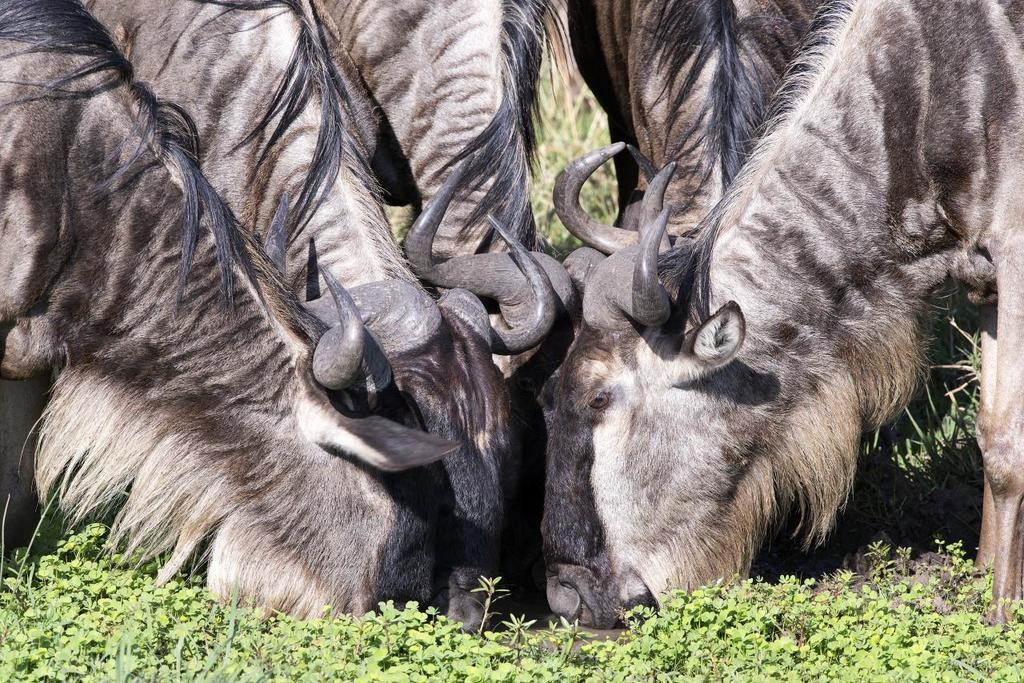What is present in the image? There are animals in the image. What are the animals doing? The animals are drinking water. What is the ground covered with? There is green grass on the ground in the image. Are there any plants visible? Yes, there are small plants in the image. What type of soup is being served to the kitten in the image? There is no kitten or soup present in the image. 